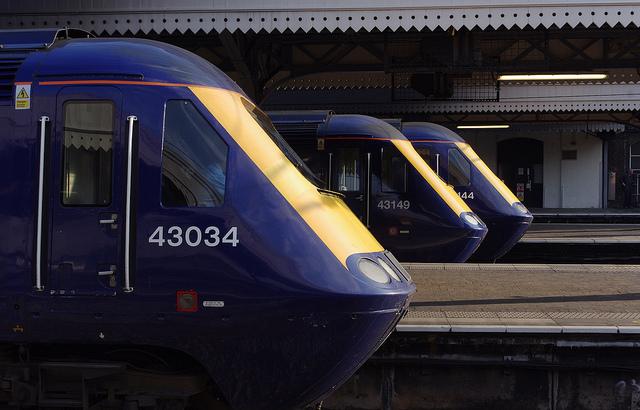What number is the train closest to the camera?
Concise answer only. 43034. How many trains are there?
Give a very brief answer. 3. What color is the trains?
Answer briefly. Blue. 